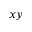<formula> <loc_0><loc_0><loc_500><loc_500>x y</formula> 